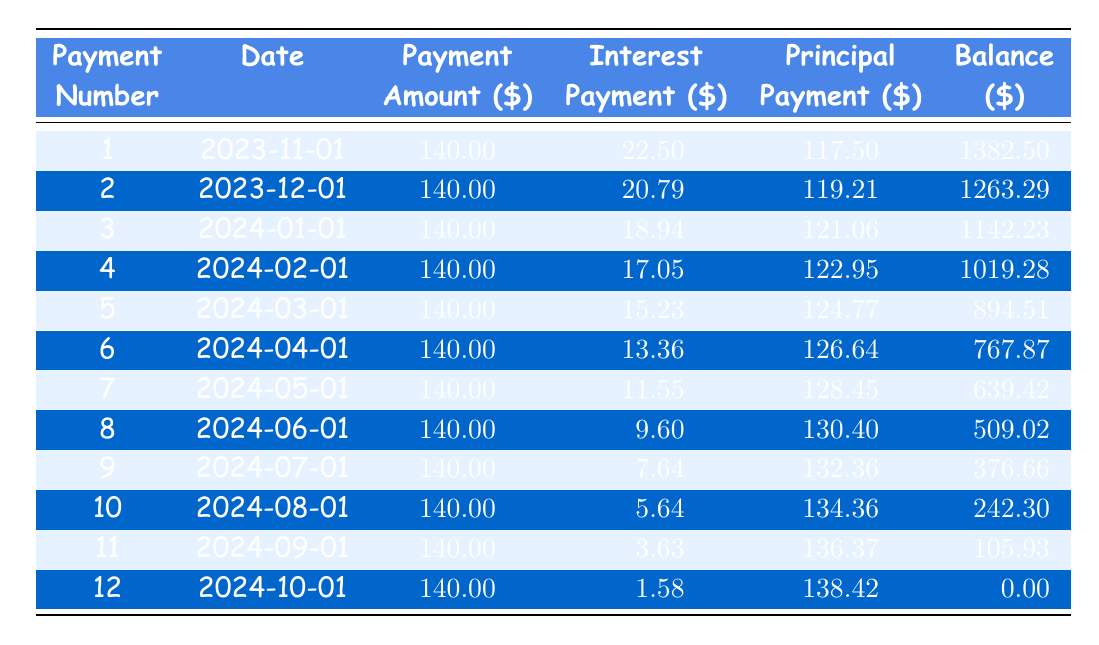What is the payment amount for the first installment? The first installment shows a payment amount of 140.00 in the table.
Answer: 140.00 How much interest was paid in the second installment? The table shows that the interest payment for the second installment is 20.79.
Answer: 20.79 What is the total principal payment after the first three installments? The principal payments of the first three installments are 117.50, 119.21, and 121.06. Summing them gives 117.50 + 119.21 + 121.06 = 357.77.
Answer: 357.77 Is the remaining balance after the fourth payment less than 1000? The remaining balance after the fourth payment is 1019.28, which is greater than 1000, so the answer is false.
Answer: No Which installment had the highest principal payment and what was that amount? By examining the principal payments from the table, the highest principal payment is from the twelfth installment, which is 138.42.
Answer: 138.42 How much total interest will be paid over the entire repayment period? Summing all interest payments from the table gives: 22.50 + 20.79 + 18.94 + 17.05 + 15.23 + 13.36 + 11.55 + 9.60 + 7.64 + 5.64 + 3.63 + 1.58 =  146.50.
Answer: 146.50 How does the principal payment in the eighth installment compare to the second installment? The principal payment in the eighth installment is 130.40, while in the second installment it is 119.21. Comparing these, 130.40 is greater than 119.21.
Answer: Greater What is the average monthly interest payment over the 12-month term? Calculate the total interest paid during the 12 months which is 146.50 and divide it by 12 resulting in an average interest payment of 146.50 / 12 = 12.21.
Answer: 12.21 What is the remaining balance after the sixth payment? The remaining balance after the sixth payment, as shown in the table, is 767.87.
Answer: 767.87 